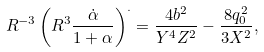Convert formula to latex. <formula><loc_0><loc_0><loc_500><loc_500>R ^ { - 3 } \left ( R ^ { 3 } \frac { \dot { \alpha } } { 1 + \alpha } \right ) ^ { . } = \frac { 4 b ^ { 2 } } { Y ^ { 4 } Z ^ { 2 } } - \frac { 8 q _ { 0 } ^ { 2 } } { 3 X ^ { 2 } } ,</formula> 